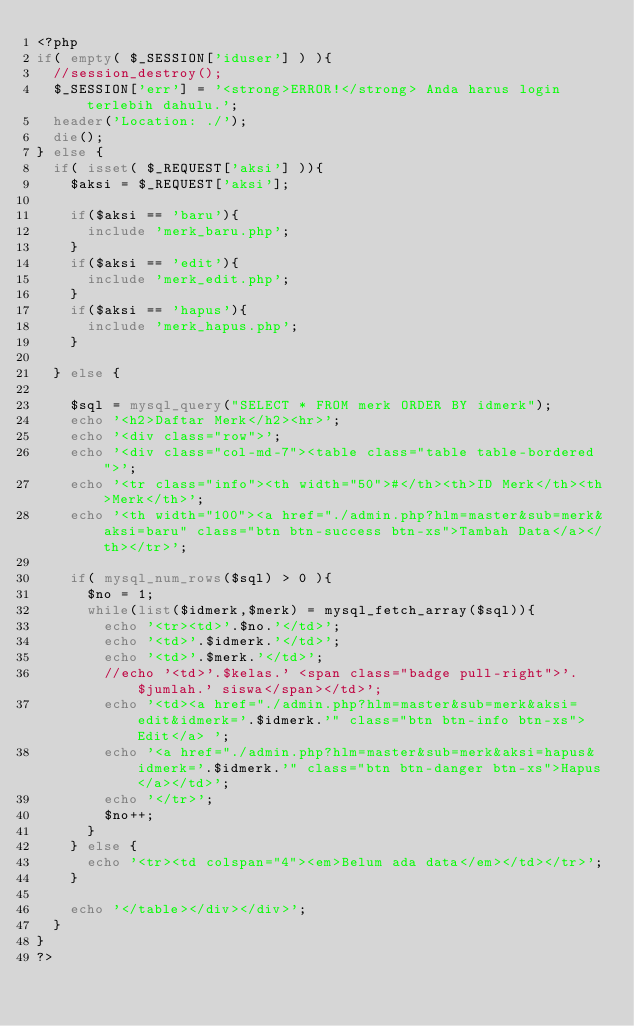<code> <loc_0><loc_0><loc_500><loc_500><_PHP_><?php
if( empty( $_SESSION['iduser'] ) ){
	//session_destroy();
	$_SESSION['err'] = '<strong>ERROR!</strong> Anda harus login terlebih dahulu.';
	header('Location: ./');
	die();
} else {
	if( isset( $_REQUEST['aksi'] )){
		$aksi = $_REQUEST['aksi'];
		
		if($aksi == 'baru'){
			include 'merk_baru.php';
		}
		if($aksi == 'edit'){
			include 'merk_edit.php';
		}
		if($aksi == 'hapus'){
			include 'merk_hapus.php';
		}
		
	} else {

		$sql = mysql_query("SELECT * FROM merk ORDER BY idmerk");
		echo '<h2>Daftar Merk</h2><hr>';
		echo '<div class="row">';
		echo '<div class="col-md-7"><table class="table table-bordered">';
		echo '<tr class="info"><th width="50">#</th><th>ID Merk</th><th>Merk</th>';
		echo '<th width="100"><a href="./admin.php?hlm=master&sub=merk&aksi=baru" class="btn btn-success btn-xs">Tambah Data</a></th></tr>';
		
		if( mysql_num_rows($sql) > 0 ){
			$no = 1;
			while(list($idmerk,$merk) = mysql_fetch_array($sql)){
				echo '<tr><td>'.$no.'</td>';
				echo '<td>'.$idmerk.'</td>';
				echo '<td>'.$merk.'</td>';
				//echo '<td>'.$kelas.' <span class="badge pull-right">'.$jumlah.' siswa</span></td>';
				echo '<td><a href="./admin.php?hlm=master&sub=merk&aksi=edit&idmerk='.$idmerk.'" class="btn btn-info btn-xs">Edit</a> ';
				echo '<a href="./admin.php?hlm=master&sub=merk&aksi=hapus&idmerk='.$idmerk.'" class="btn btn-danger btn-xs">Hapus</a></td>';
				echo '</tr>';
				$no++;
			}
		} else {
			echo '<tr><td colspan="4"><em>Belum ada data</em></td></tr>';
		}
		
		echo '</table></div></div>';
	}
}
?></code> 